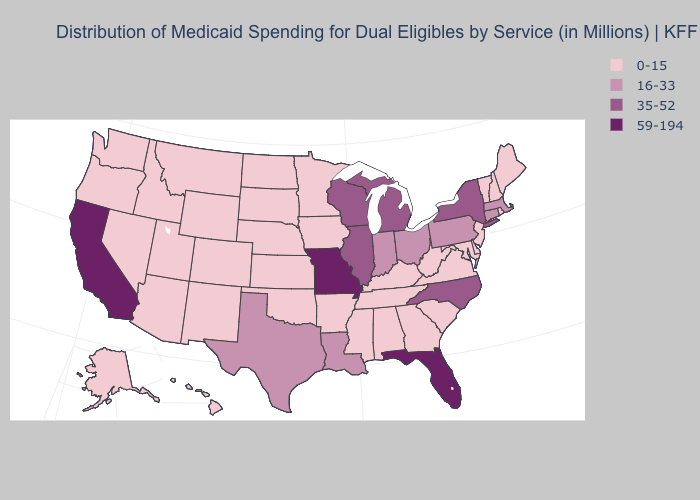What is the highest value in the MidWest ?
Answer briefly. 59-194. Which states have the highest value in the USA?
Quick response, please. California, Florida, Missouri. Which states have the highest value in the USA?
Keep it brief. California, Florida, Missouri. What is the lowest value in states that border Oklahoma?
Keep it brief. 0-15. What is the value of West Virginia?
Short answer required. 0-15. Does Louisiana have the lowest value in the South?
Short answer required. No. Name the states that have a value in the range 0-15?
Short answer required. Alabama, Alaska, Arizona, Arkansas, Colorado, Delaware, Georgia, Hawaii, Idaho, Iowa, Kansas, Kentucky, Maine, Maryland, Minnesota, Mississippi, Montana, Nebraska, Nevada, New Hampshire, New Jersey, New Mexico, North Dakota, Oklahoma, Oregon, Rhode Island, South Carolina, South Dakota, Tennessee, Utah, Vermont, Virginia, Washington, West Virginia, Wyoming. How many symbols are there in the legend?
Quick response, please. 4. Among the states that border West Virginia , does Pennsylvania have the highest value?
Be succinct. Yes. Name the states that have a value in the range 59-194?
Quick response, please. California, Florida, Missouri. Name the states that have a value in the range 0-15?
Answer briefly. Alabama, Alaska, Arizona, Arkansas, Colorado, Delaware, Georgia, Hawaii, Idaho, Iowa, Kansas, Kentucky, Maine, Maryland, Minnesota, Mississippi, Montana, Nebraska, Nevada, New Hampshire, New Jersey, New Mexico, North Dakota, Oklahoma, Oregon, Rhode Island, South Carolina, South Dakota, Tennessee, Utah, Vermont, Virginia, Washington, West Virginia, Wyoming. Does Arkansas have the same value as Pennsylvania?
Give a very brief answer. No. Name the states that have a value in the range 0-15?
Write a very short answer. Alabama, Alaska, Arizona, Arkansas, Colorado, Delaware, Georgia, Hawaii, Idaho, Iowa, Kansas, Kentucky, Maine, Maryland, Minnesota, Mississippi, Montana, Nebraska, Nevada, New Hampshire, New Jersey, New Mexico, North Dakota, Oklahoma, Oregon, Rhode Island, South Carolina, South Dakota, Tennessee, Utah, Vermont, Virginia, Washington, West Virginia, Wyoming. Does the first symbol in the legend represent the smallest category?
Give a very brief answer. Yes. Name the states that have a value in the range 35-52?
Keep it brief. Illinois, Michigan, New York, North Carolina, Wisconsin. 